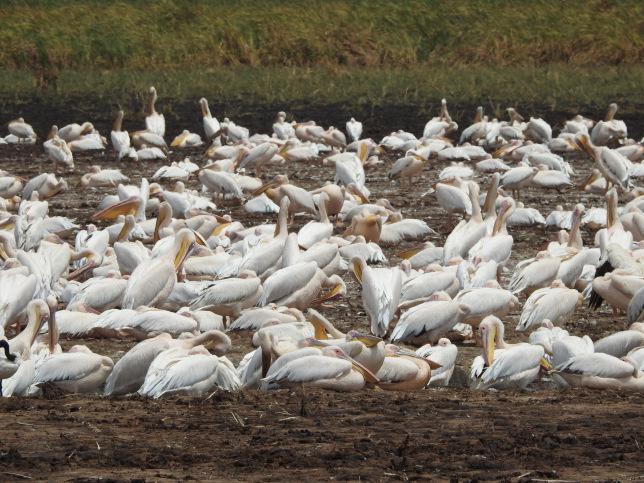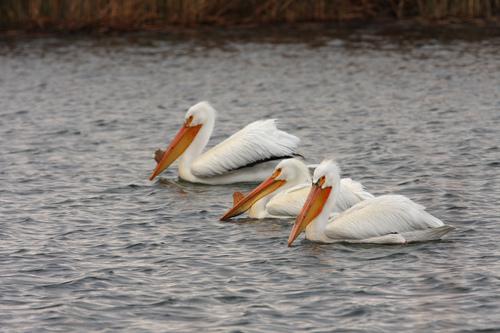The first image is the image on the left, the second image is the image on the right. Considering the images on both sides, is "An image features exactly three pelicans, all facing the same way." valid? Answer yes or no. Yes. The first image is the image on the left, the second image is the image on the right. Analyze the images presented: Is the assertion "The rightmost image has 3 birds." valid? Answer yes or no. Yes. 